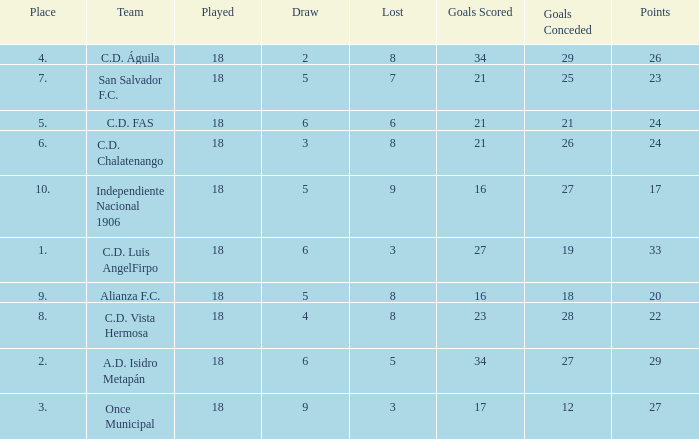How many points were in a game that had a lost of 5, greater than place 2, and 27 goals conceded? 0.0. 